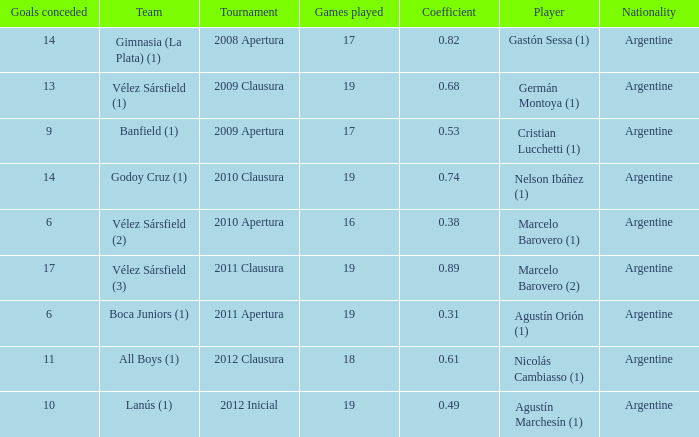What is the nationality of the 2012 clausura  tournament? Argentine. 